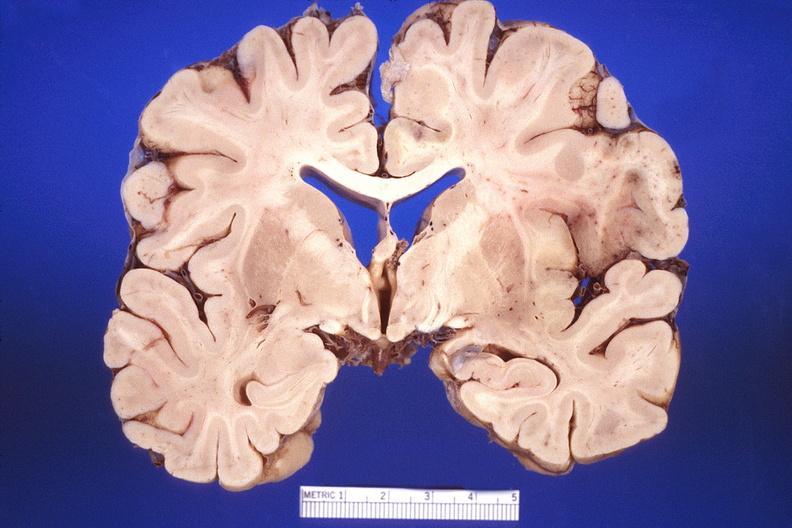does this great toe show brain, herpes encephalitis?
Answer the question using a single word or phrase. No 